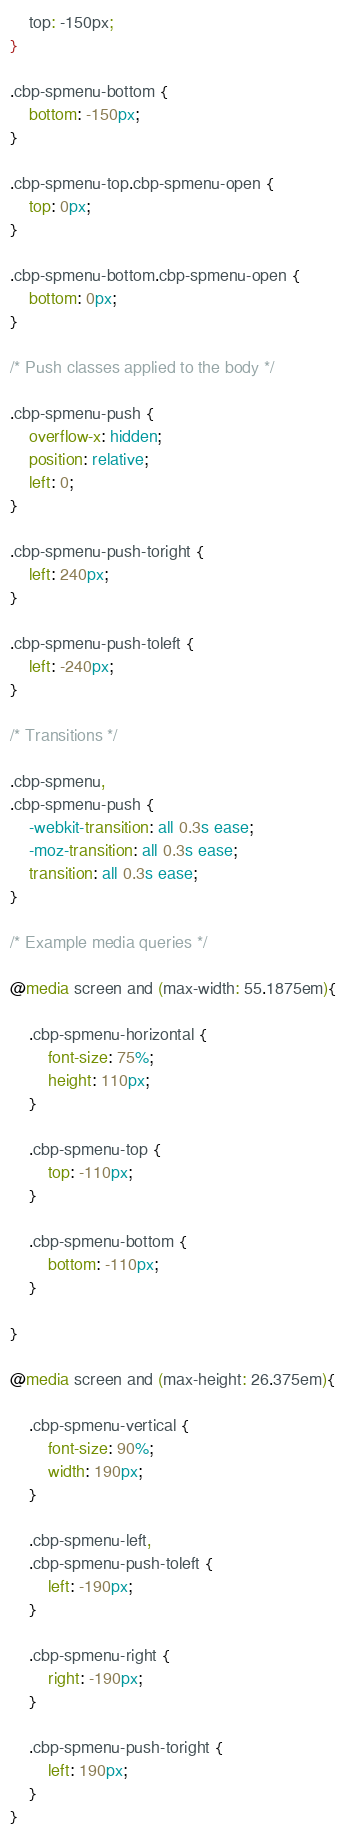<code> <loc_0><loc_0><loc_500><loc_500><_CSS_>	top: -150px;
}

.cbp-spmenu-bottom {
	bottom: -150px;
}

.cbp-spmenu-top.cbp-spmenu-open {
	top: 0px;
}

.cbp-spmenu-bottom.cbp-spmenu-open {
	bottom: 0px;
}

/* Push classes applied to the body */

.cbp-spmenu-push {
	overflow-x: hidden;
	position: relative;
	left: 0;
}

.cbp-spmenu-push-toright {
	left: 240px;
}

.cbp-spmenu-push-toleft {
	left: -240px;
}

/* Transitions */

.cbp-spmenu,
.cbp-spmenu-push {
	-webkit-transition: all 0.3s ease;
	-moz-transition: all 0.3s ease;
	transition: all 0.3s ease;
}

/* Example media queries */

@media screen and (max-width: 55.1875em){

	.cbp-spmenu-horizontal {
		font-size: 75%;
		height: 110px;
	}

	.cbp-spmenu-top {
		top: -110px;
	}

	.cbp-spmenu-bottom {
		bottom: -110px;
	}

}

@media screen and (max-height: 26.375em){

	.cbp-spmenu-vertical {
		font-size: 90%;
		width: 190px;
	}

	.cbp-spmenu-left,
	.cbp-spmenu-push-toleft {
		left: -190px;
	}

	.cbp-spmenu-right {
		right: -190px;
	}

	.cbp-spmenu-push-toright {
		left: 190px;
	}
}</code> 